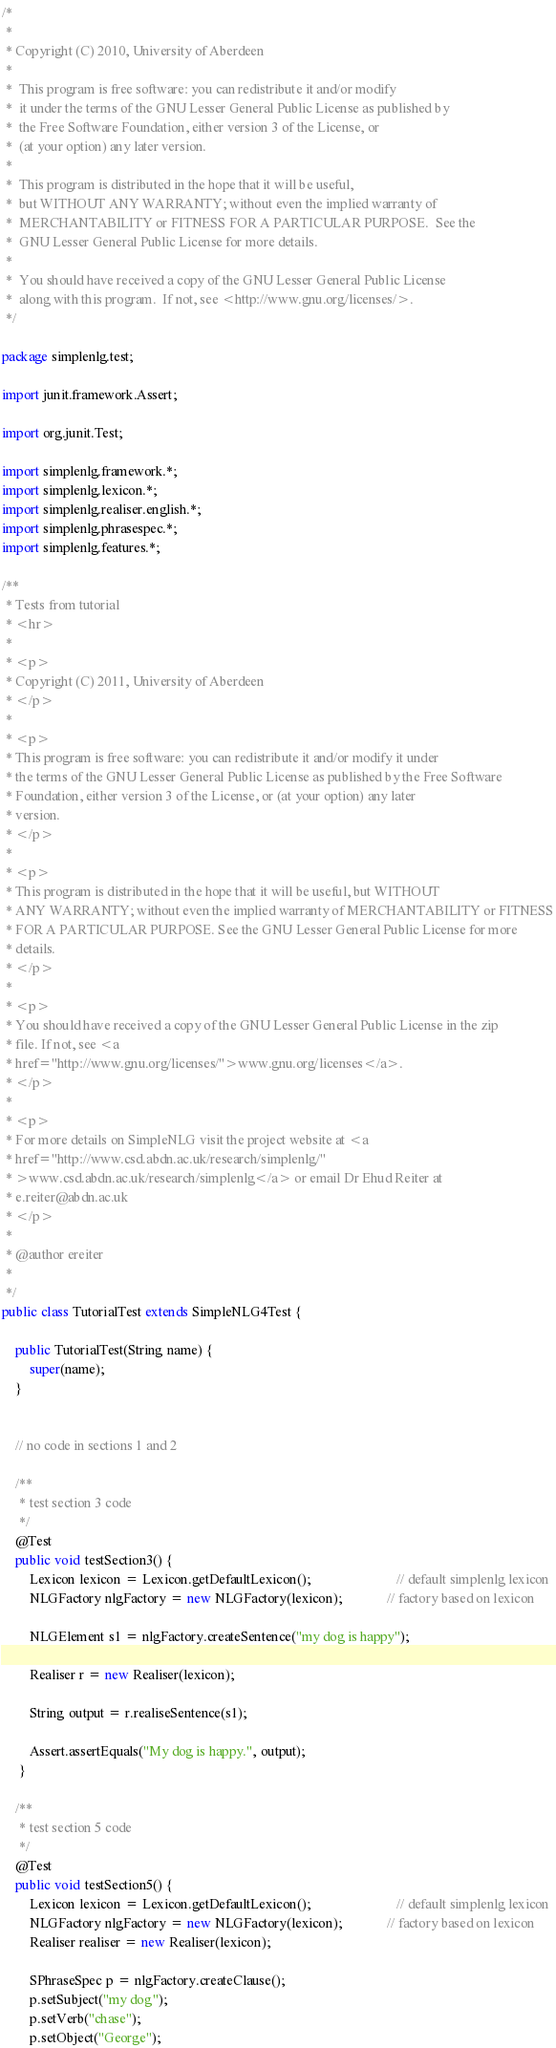<code> <loc_0><loc_0><loc_500><loc_500><_Java_>/*
 * 
 * Copyright (C) 2010, University of Aberdeen
 *
 *  This program is free software: you can redistribute it and/or modify
 *  it under the terms of the GNU Lesser General Public License as published by
 *  the Free Software Foundation, either version 3 of the License, or
 *  (at your option) any later version.
 *
 *  This program is distributed in the hope that it will be useful,
 *  but WITHOUT ANY WARRANTY; without even the implied warranty of
 *  MERCHANTABILITY or FITNESS FOR A PARTICULAR PURPOSE.  See the
 *  GNU Lesser General Public License for more details.
 *
 *  You should have received a copy of the GNU Lesser General Public License
 *  along with this program.  If not, see <http://www.gnu.org/licenses/>.
 */

package simplenlg.test;

import junit.framework.Assert;

import org.junit.Test;

import simplenlg.framework.*;
import simplenlg.lexicon.*;
import simplenlg.realiser.english.*;
import simplenlg.phrasespec.*;
import simplenlg.features.*;

/**
 * Tests from tutorial
 * <hr>
 * 
 * <p>
 * Copyright (C) 2011, University of Aberdeen
 * </p>
 * 
 * <p>
 * This program is free software: you can redistribute it and/or modify it under
 * the terms of the GNU Lesser General Public License as published by the Free Software
 * Foundation, either version 3 of the License, or (at your option) any later
 * version.
 * </p>
 * 
 * <p>
 * This program is distributed in the hope that it will be useful, but WITHOUT
 * ANY WARRANTY; without even the implied warranty of MERCHANTABILITY or FITNESS
 * FOR A PARTICULAR PURPOSE. See the GNU Lesser General Public License for more
 * details.
 * </p>
 * 
 * <p>
 * You should have received a copy of the GNU Lesser General Public License in the zip
 * file. If not, see <a
 * href="http://www.gnu.org/licenses/">www.gnu.org/licenses</a>.
 * </p>
 * 
 * <p>
 * For more details on SimpleNLG visit the project website at <a
 * href="http://www.csd.abdn.ac.uk/research/simplenlg/"
 * >www.csd.abdn.ac.uk/research/simplenlg</a> or email Dr Ehud Reiter at
 * e.reiter@abdn.ac.uk
 * </p>
 * 
 * @author ereiter
 * 
 */
public class TutorialTest extends SimpleNLG4Test {

	public TutorialTest(String name) {
		super(name);
	}


	// no code in sections 1 and 2
	
	/**
	 * test section 3 code
	 */
	@Test
	public void testSection3() {
		Lexicon lexicon = Lexicon.getDefaultLexicon();                         // default simplenlg lexicon
		NLGFactory nlgFactory = new NLGFactory(lexicon);             // factory based on lexicon

		NLGElement s1 = nlgFactory.createSentence("my dog is happy");
		
		Realiser r = new Realiser(lexicon);
		
		String output = r.realiseSentence(s1);
		
		Assert.assertEquals("My dog is happy.", output);
	 }
	
	/**
	 * test section 5 code
	 */
	@Test
	public void testSection5() {
		Lexicon lexicon = Lexicon.getDefaultLexicon();                         // default simplenlg lexicon
		NLGFactory nlgFactory = new NLGFactory(lexicon);             // factory based on lexicon
		Realiser realiser = new Realiser(lexicon);
		
		SPhraseSpec p = nlgFactory.createClause();
		p.setSubject("my dog");
		p.setVerb("chase");
		p.setObject("George");</code> 